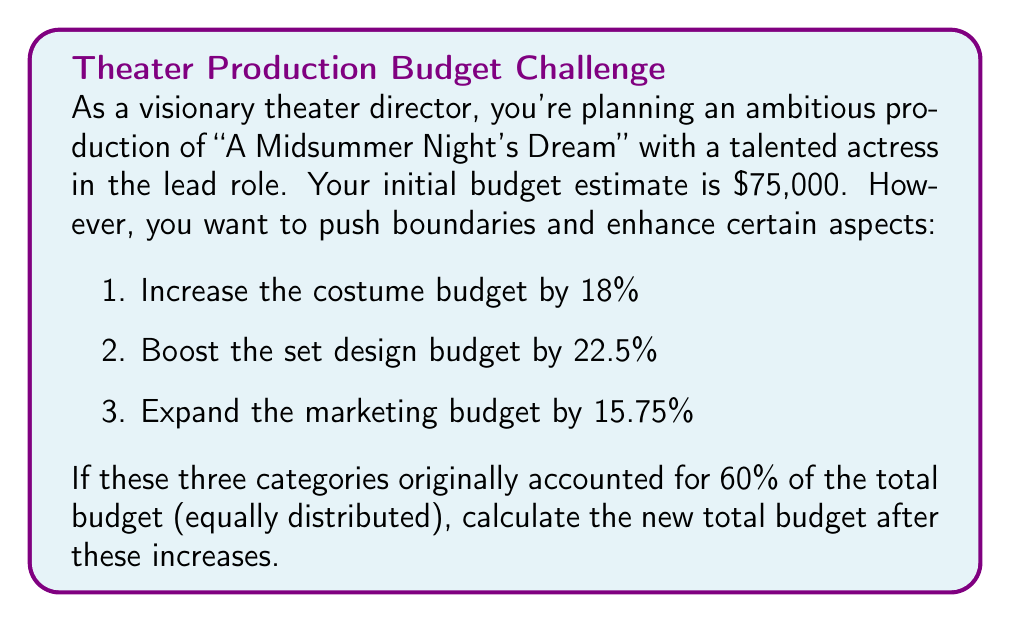Solve this math problem. Let's approach this step-by-step:

1. Calculate the original amount for each category:
   60% of $75,000 = $75,000 × 0.60 = $45,000
   Each category (costume, set design, marketing) = $45,000 ÷ 3 = $15,000

2. Calculate the increases for each category:
   Costume: $15,000 × 1.18 = $17,700
   Set design: $15,000 × 1.225 = $18,375
   Marketing: $15,000 × 1.1575 = $17,362.50

3. Calculate the total increase:
   Total increase = $(17,700 + 18,375 + 17,362.50) - (15,000 × 3)
                  = $53,437.50 - $45,000
                  = $8,437.50

4. Add the increase to the original budget:
   New total budget = $75,000 + $8,437.50 = $83,437.50

The mathematical representation:

$$\text{New Budget} = 75000 + (15000 \times 0.18 + 15000 \times 0.225 + 15000 \times 0.1575)$$
$$= 75000 + (2700 + 3375 + 2362.50)$$
$$= 75000 + 8437.50$$
$$= 83437.50$$
Answer: $83,437.50 